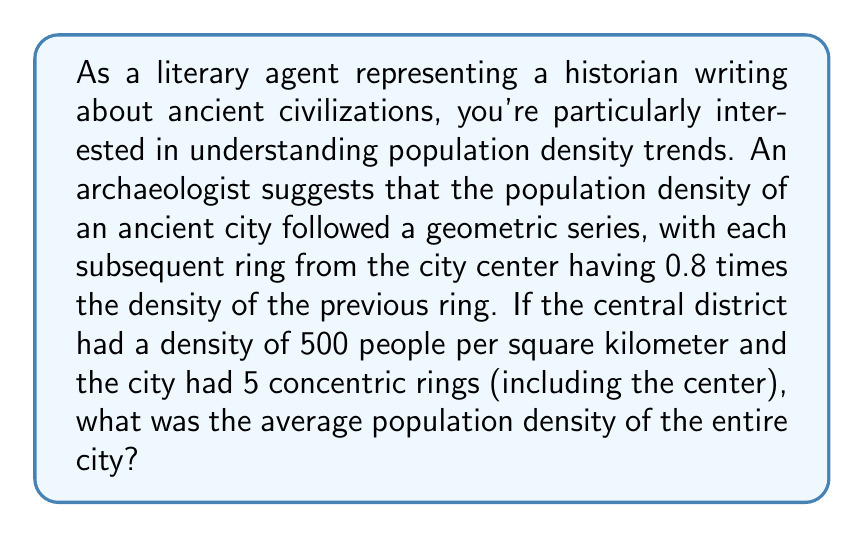What is the answer to this math problem? To solve this problem, we need to use the concept of geometric series and weighted averages. Let's approach this step-by-step:

1) First, let's define our geometric series. The population densities for each ring are:
   Ring 0 (center): $500$ people/km²
   Ring 1: $500 \cdot 0.8 = 400$ people/km²
   Ring 2: $500 \cdot 0.8^2 = 320$ people/km²
   Ring 3: $500 \cdot 0.8^3 = 256$ people/km²
   Ring 4: $500 \cdot 0.8^4 = 204.8$ people/km²

2) Now, we need to consider the areas of these rings. Assuming the rings are of equal width, their areas will form an arithmetic sequence:
   Ring 0: $A$
   Ring 1: $3A$
   Ring 2: $5A$
   Ring 3: $7A$
   Ring 4: $9A$
   Where $A$ is some constant area.

3) To find the average density, we need to calculate the total population divided by the total area:

   $$\text{Average Density} = \frac{\text{Total Population}}{\text{Total Area}}$$

4) Total Population:
   $$(500A) + (400 \cdot 3A) + (320 \cdot 5A) + (256 \cdot 7A) + (204.8 \cdot 9A)$$
   $$= A(500 + 1200 + 1600 + 1792 + 1843.2)$$
   $$= 6935.2A$$

5) Total Area:
   $$A + 3A + 5A + 7A + 9A = 25A$$

6) Therefore, the average density is:
   $$\text{Average Density} = \frac{6935.2A}{25A} = 277.408$$ people/km²
Answer: The average population density of the entire ancient city is approximately 277.4 people per square kilometer. 